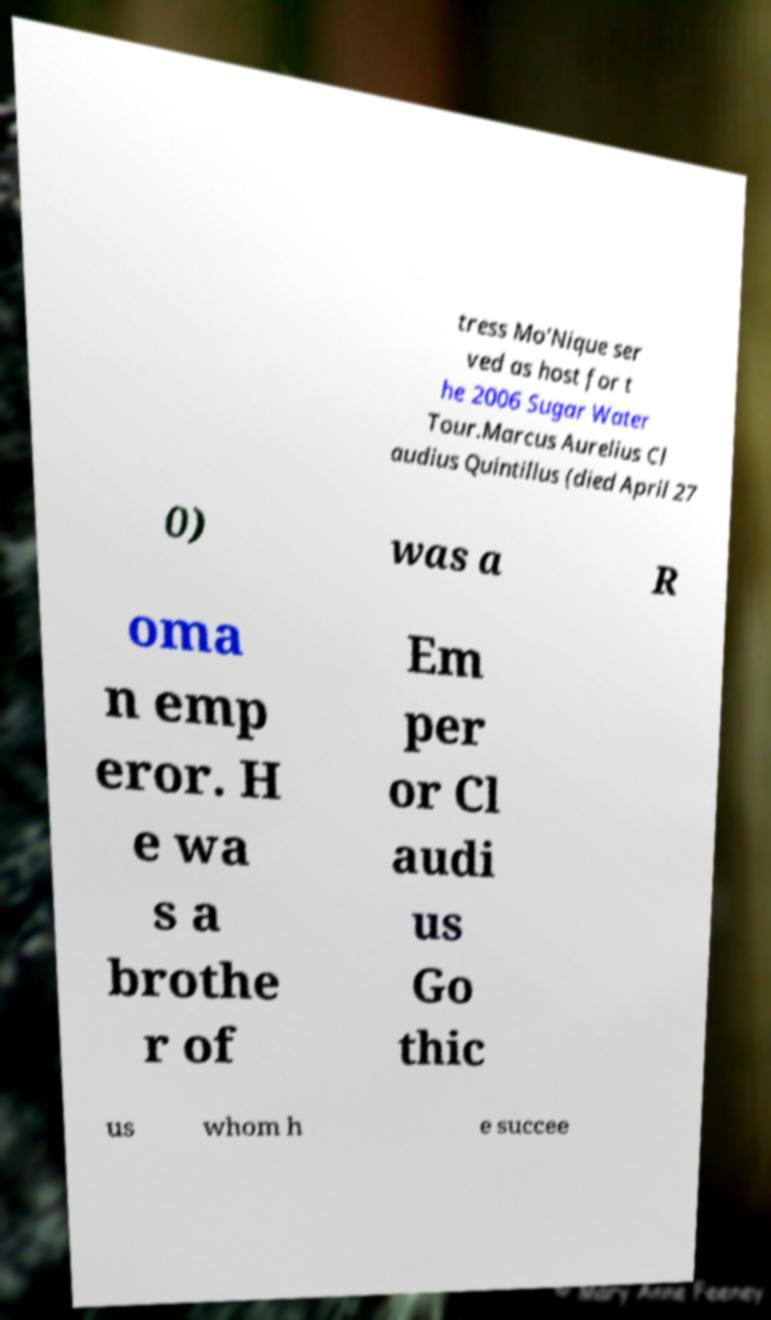Can you accurately transcribe the text from the provided image for me? tress Mo'Nique ser ved as host for t he 2006 Sugar Water Tour.Marcus Aurelius Cl audius Quintillus (died April 27 0) was a R oma n emp eror. H e wa s a brothe r of Em per or Cl audi us Go thic us whom h e succee 